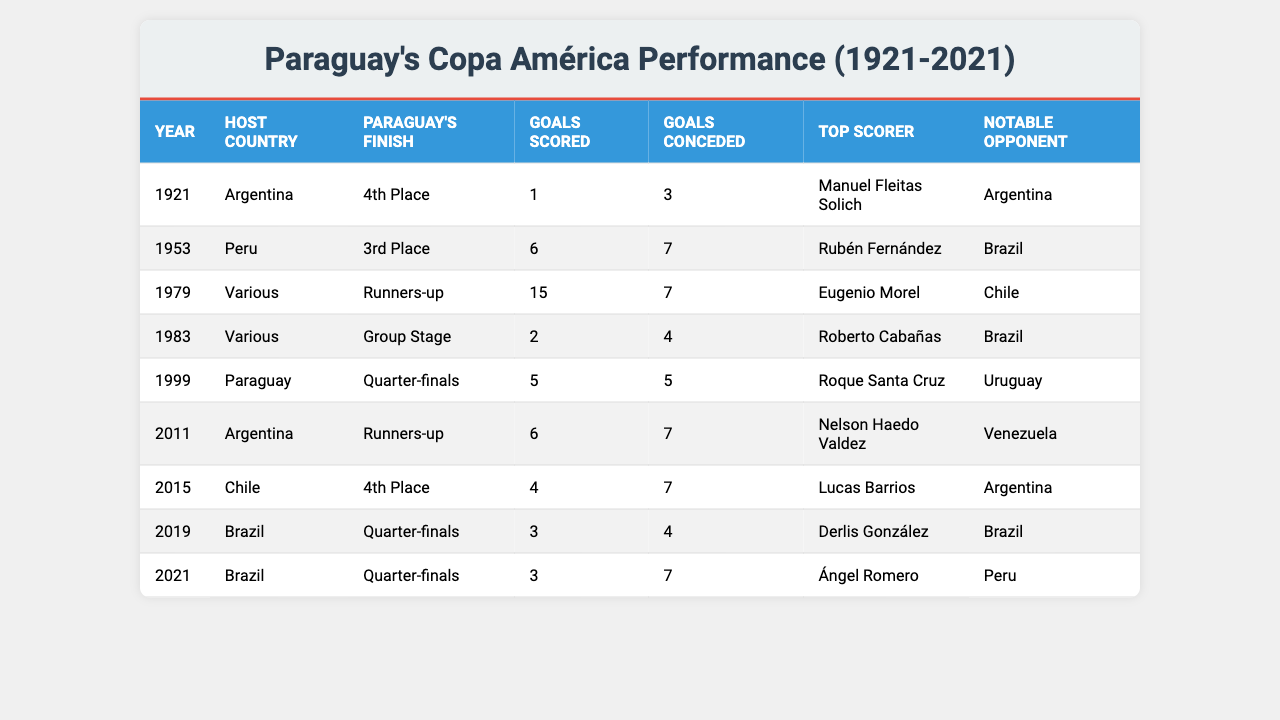What was Paraguay's finish in the 1983 Copa América? The table shows that in 1983, Paraguay finished in the Group Stage.
Answer: Group Stage Who was the top scorer for Paraguay in the 2011 Copa América? According to the table, the top scorer for Paraguay in 2011 was Nelson Haedo Valdez.
Answer: Nelson Haedo Valdez Which Copa América tournaments did Paraguay finish as runners-up? The table reveals that Paraguay finished as runners-up in the tournaments of 1979 and 2011.
Answer: 1979, 2011 What is the total number of goals scored by Paraguay in the Copa América tournaments listed? By adding the goals scored: 1 + 6 + 15 + 2 + 5 + 6 + 4 + 3 + 3 = 45 goals.
Answer: 45 How many goals did Paraguay concede in total across all tournaments listed? Adding the goals conceded gives: 3 + 7 + 7 + 4 + 5 + 7 + 7 + 4 + 7 = 51 goals conceded in total.
Answer: 51 Did Paraguay ever finish in the top three in the Copa América tournaments listed? Yes, the table indicates Paraguay finished 4th, 3rd, and as runners-up, which are all positions within the top three.
Answer: Yes In which Copa América did Paraguay host the tournament? The table shows that Paraguay hosted the tournament in 1999, as highlighted in the "Host Country" column.
Answer: 1999 What was the average number of goals scored by Paraguay in the tournaments listed? To find the average, total goals (45) divided by the number of tournaments (9) gives approximately 5. Therefore, average goals scored by Paraguay is 5.
Answer: 5 Which notable opponent did Paraguay face in the finals when they finished as runners-up? The table indicates that in 1979, Paraguay's notable opponent was Chile when they finished as runners-up.
Answer: Chile Which year did Paraguay score the highest number of goals in the Copa América? Looking at the table, Paraguay scored the most goals (15) in the 1979 Copa América.
Answer: 1979 